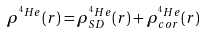Convert formula to latex. <formula><loc_0><loc_0><loc_500><loc_500>\rho ^ { ^ { 4 } H e } ( r ) = \rho _ { S D } ^ { ^ { 4 } H e } ( r ) + \rho _ { c o r } ^ { ^ { 4 } H e } ( r )</formula> 